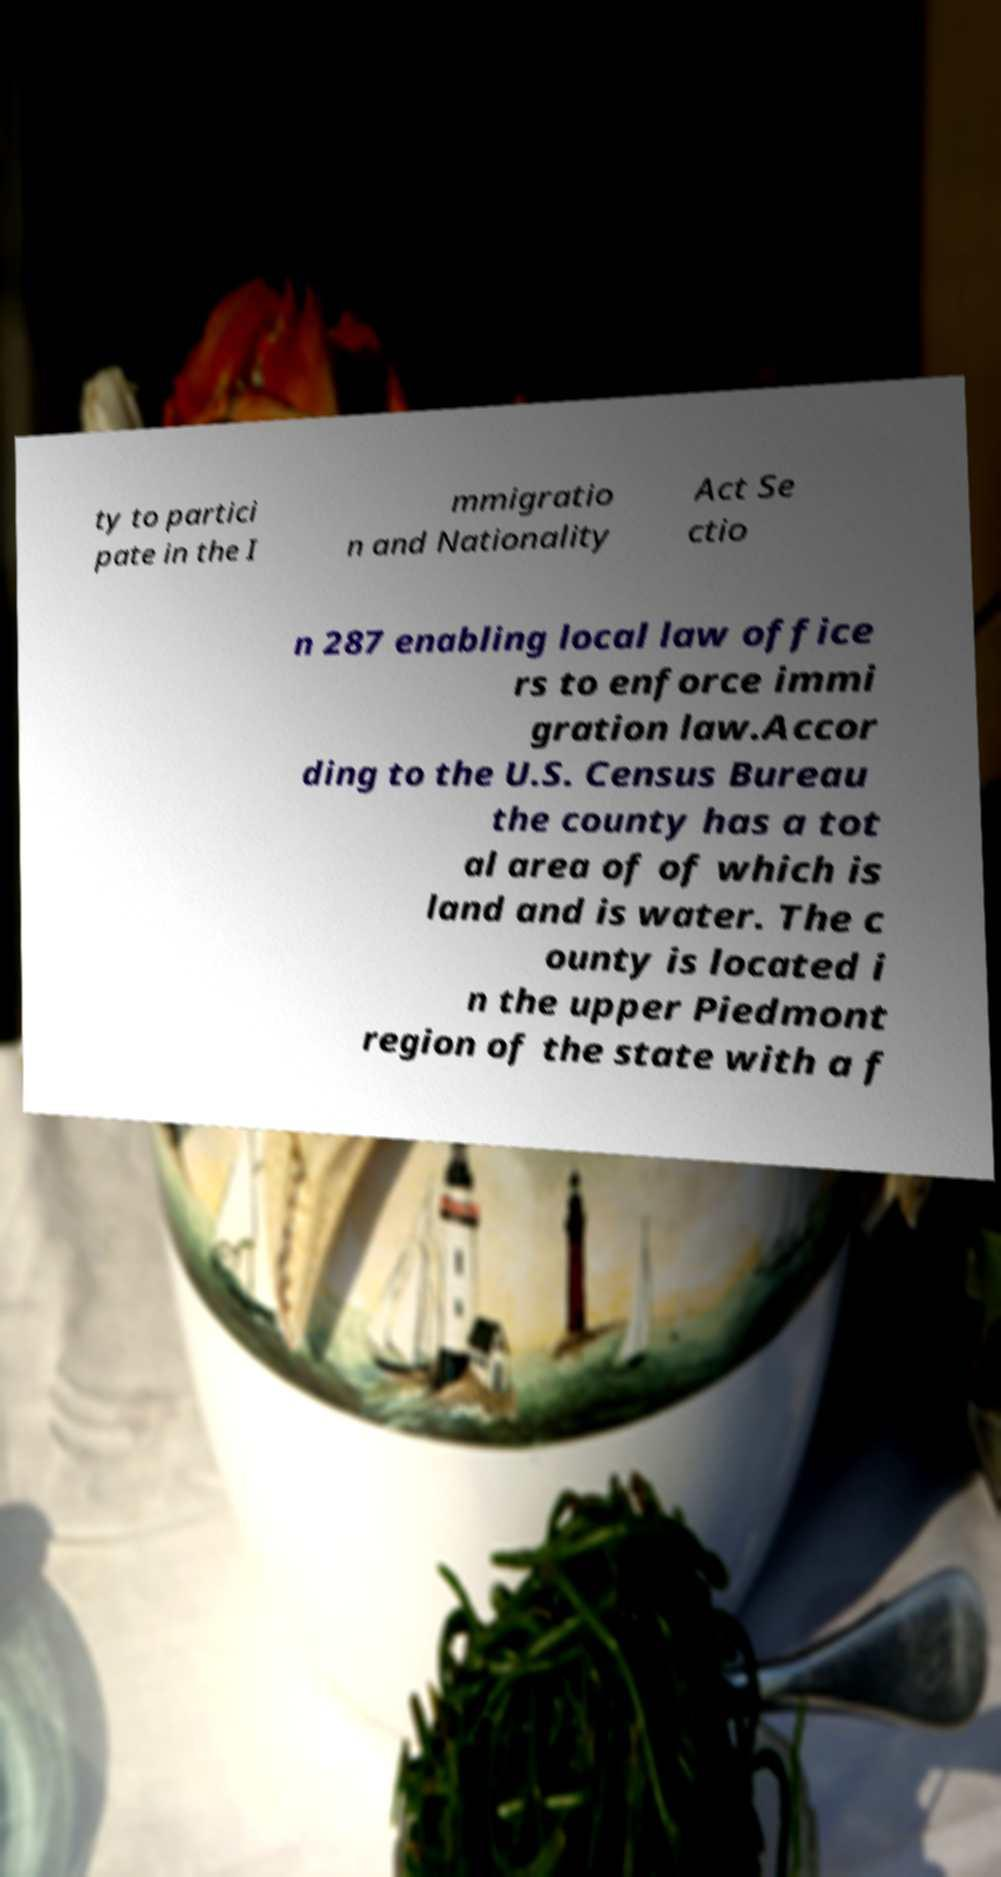Please identify and transcribe the text found in this image. ty to partici pate in the I mmigratio n and Nationality Act Se ctio n 287 enabling local law office rs to enforce immi gration law.Accor ding to the U.S. Census Bureau the county has a tot al area of of which is land and is water. The c ounty is located i n the upper Piedmont region of the state with a f 